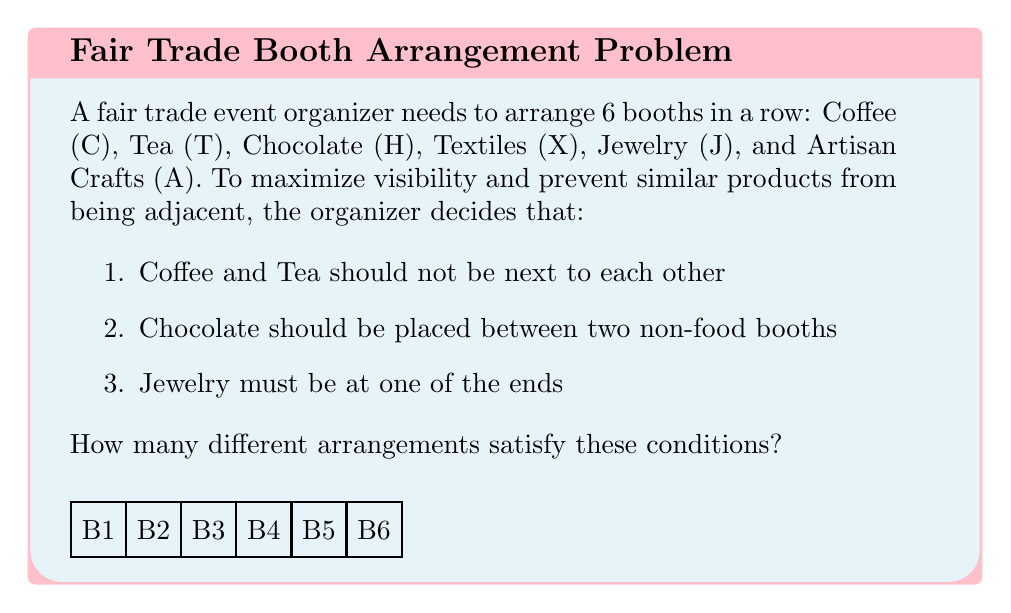What is the answer to this math problem? Let's approach this step-by-step:

1) First, let's consider the placement of Jewelry (J). It must be at one of the ends, so we have 2 choices for its position.

2) Now, we need to place Chocolate (H) between two non-food booths. There are 4 positions left, and we need to choose 2 non-food booths to surround H. The non-food booths are X, A, and J (which we've already placed).

3) If J is at the left end, H can be in positions 3 or 5.
   If J is at the right end, H can be in positions 2 or 4.

4) Let's consider these cases separately:

   Case 1: J at left end, H in position 3
   Arrangement: J _ H _ _ _
   We need to fill the blanks with C, T, X, A (remembering C and T can't be adjacent)
   This can be done in 2 ways: J X H A C T or J X H A T C

   Case 2: J at left end, H in position 5
   Arrangement: J _ _ _ H _
   We can fill this in 2 ways: J X A C H T or J X A T H C

   Case 3: J at right end, H in position 2
   Arrangement: _ H _ _ _ J
   This can be filled in 2 ways: X H A C T J or X H A T C J

   Case 4: J at right end, H in position 4
   Arrangement: _ _ _ H _ J
   This can be filled in 2 ways: X A C H T J or X A T H C J

5) Each case gives us 2 valid arrangements, and we have 4 cases in total.

6) Therefore, the total number of valid arrangements is $2 * 4 = 8$.
Answer: 8 